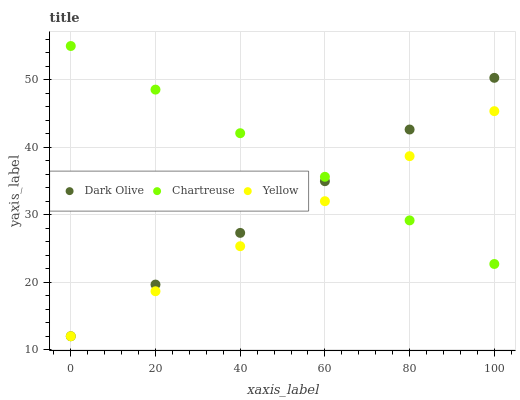Does Yellow have the minimum area under the curve?
Answer yes or no. Yes. Does Chartreuse have the maximum area under the curve?
Answer yes or no. Yes. Does Dark Olive have the minimum area under the curve?
Answer yes or no. No. Does Dark Olive have the maximum area under the curve?
Answer yes or no. No. Is Dark Olive the smoothest?
Answer yes or no. Yes. Is Chartreuse the roughest?
Answer yes or no. Yes. Is Yellow the smoothest?
Answer yes or no. No. Is Yellow the roughest?
Answer yes or no. No. Does Dark Olive have the lowest value?
Answer yes or no. Yes. Does Chartreuse have the highest value?
Answer yes or no. Yes. Does Dark Olive have the highest value?
Answer yes or no. No. Does Chartreuse intersect Yellow?
Answer yes or no. Yes. Is Chartreuse less than Yellow?
Answer yes or no. No. Is Chartreuse greater than Yellow?
Answer yes or no. No. 